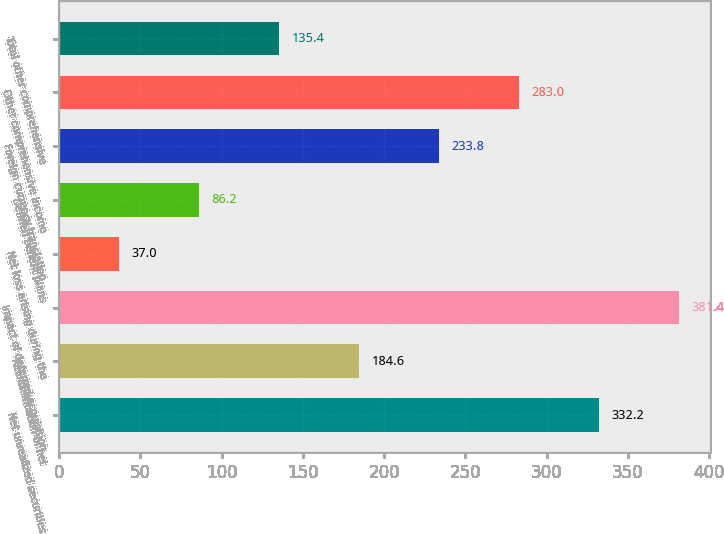Convert chart to OTSL. <chart><loc_0><loc_0><loc_500><loc_500><bar_chart><fcel>Net unrealized securities<fcel>Reclassification of net<fcel>Impact of deferred acquisition<fcel>Net loss arising during the<fcel>Defined benefit plans<fcel>Foreign currency translation<fcel>Other comprehensive income<fcel>Total other comprehensive<nl><fcel>332.2<fcel>184.6<fcel>381.4<fcel>37<fcel>86.2<fcel>233.8<fcel>283<fcel>135.4<nl></chart> 